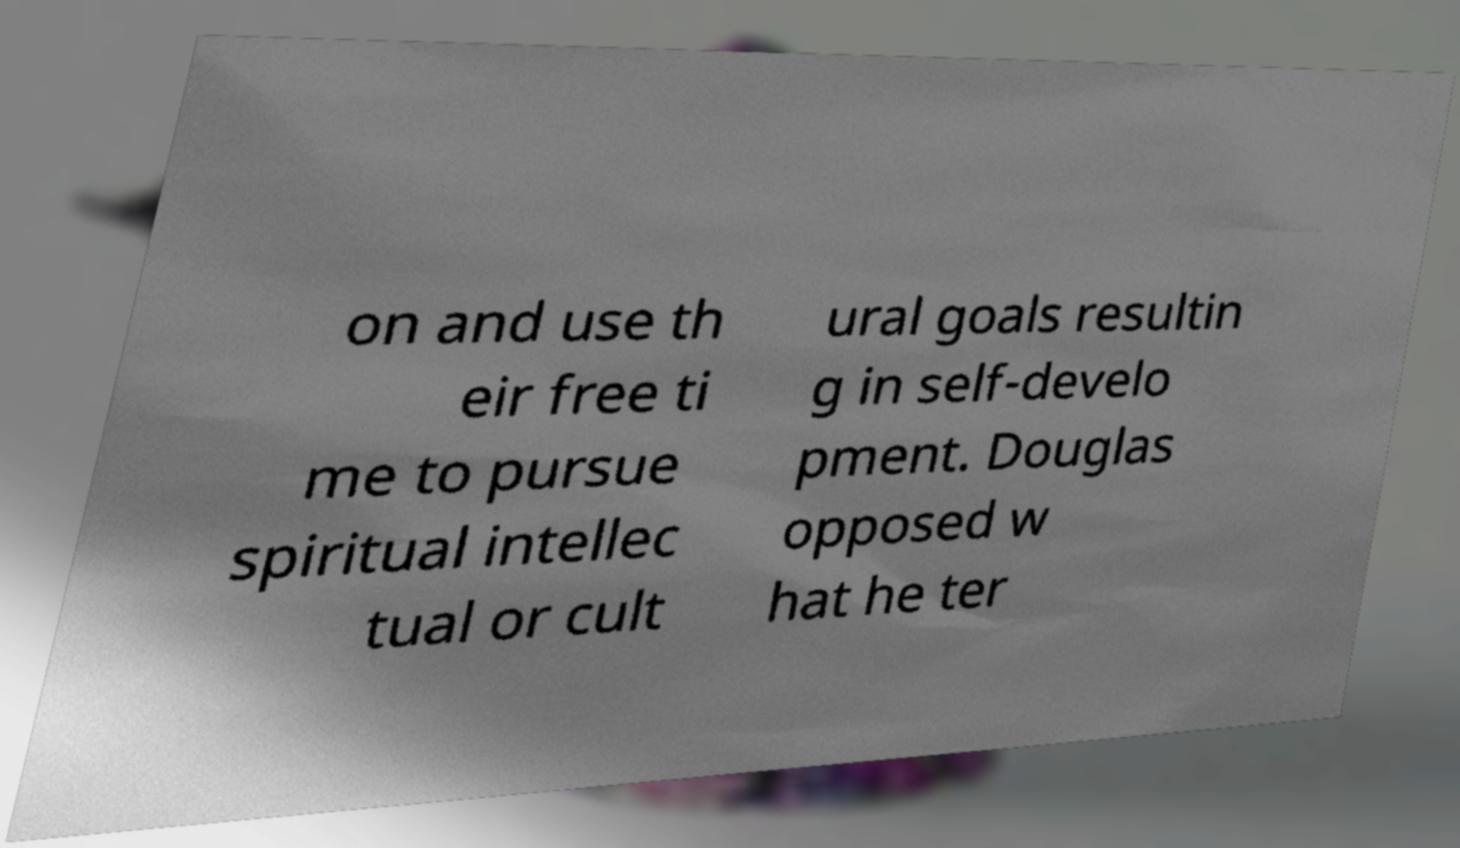Can you read and provide the text displayed in the image?This photo seems to have some interesting text. Can you extract and type it out for me? on and use th eir free ti me to pursue spiritual intellec tual or cult ural goals resultin g in self-develo pment. Douglas opposed w hat he ter 